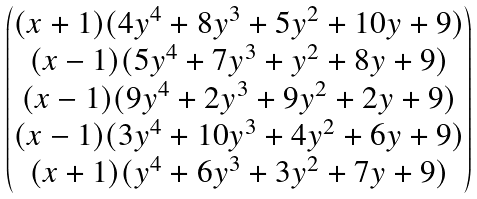<formula> <loc_0><loc_0><loc_500><loc_500>\begin{pmatrix} ( x + 1 ) ( 4 y ^ { 4 } + 8 y ^ { 3 } + 5 y ^ { 2 } + 1 0 y + 9 ) \\ ( x - 1 ) ( 5 y ^ { 4 } + 7 y ^ { 3 } + y ^ { 2 } + 8 y + 9 ) \\ ( x - 1 ) ( 9 y ^ { 4 } + 2 y ^ { 3 } + 9 y ^ { 2 } + 2 y + 9 ) \\ ( x - 1 ) ( 3 y ^ { 4 } + 1 0 y ^ { 3 } + 4 y ^ { 2 } + 6 y + 9 ) \\ ( x + 1 ) ( y ^ { 4 } + 6 y ^ { 3 } + 3 y ^ { 2 } + 7 y + 9 ) \end{pmatrix}</formula> 